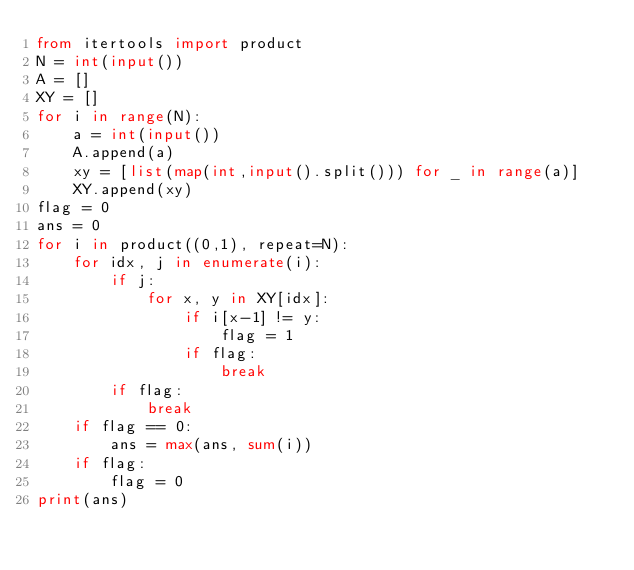<code> <loc_0><loc_0><loc_500><loc_500><_Python_>from itertools import product
N = int(input())
A = []
XY = []
for i in range(N):    
    a = int(input())
    A.append(a)
    xy = [list(map(int,input().split())) for _ in range(a)]
    XY.append(xy)
flag = 0
ans = 0
for i in product((0,1), repeat=N):
    for idx, j in enumerate(i):
        if j:
            for x, y in XY[idx]:
                if i[x-1] != y:
                    flag = 1
                if flag:
                    break
        if flag:
            break
    if flag == 0:
        ans = max(ans, sum(i))
    if flag:
        flag = 0
print(ans)</code> 